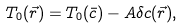<formula> <loc_0><loc_0><loc_500><loc_500>T _ { 0 } ( \vec { r } ) = T _ { 0 } ( \bar { c } ) - A \delta c ( \vec { r } ) ,</formula> 